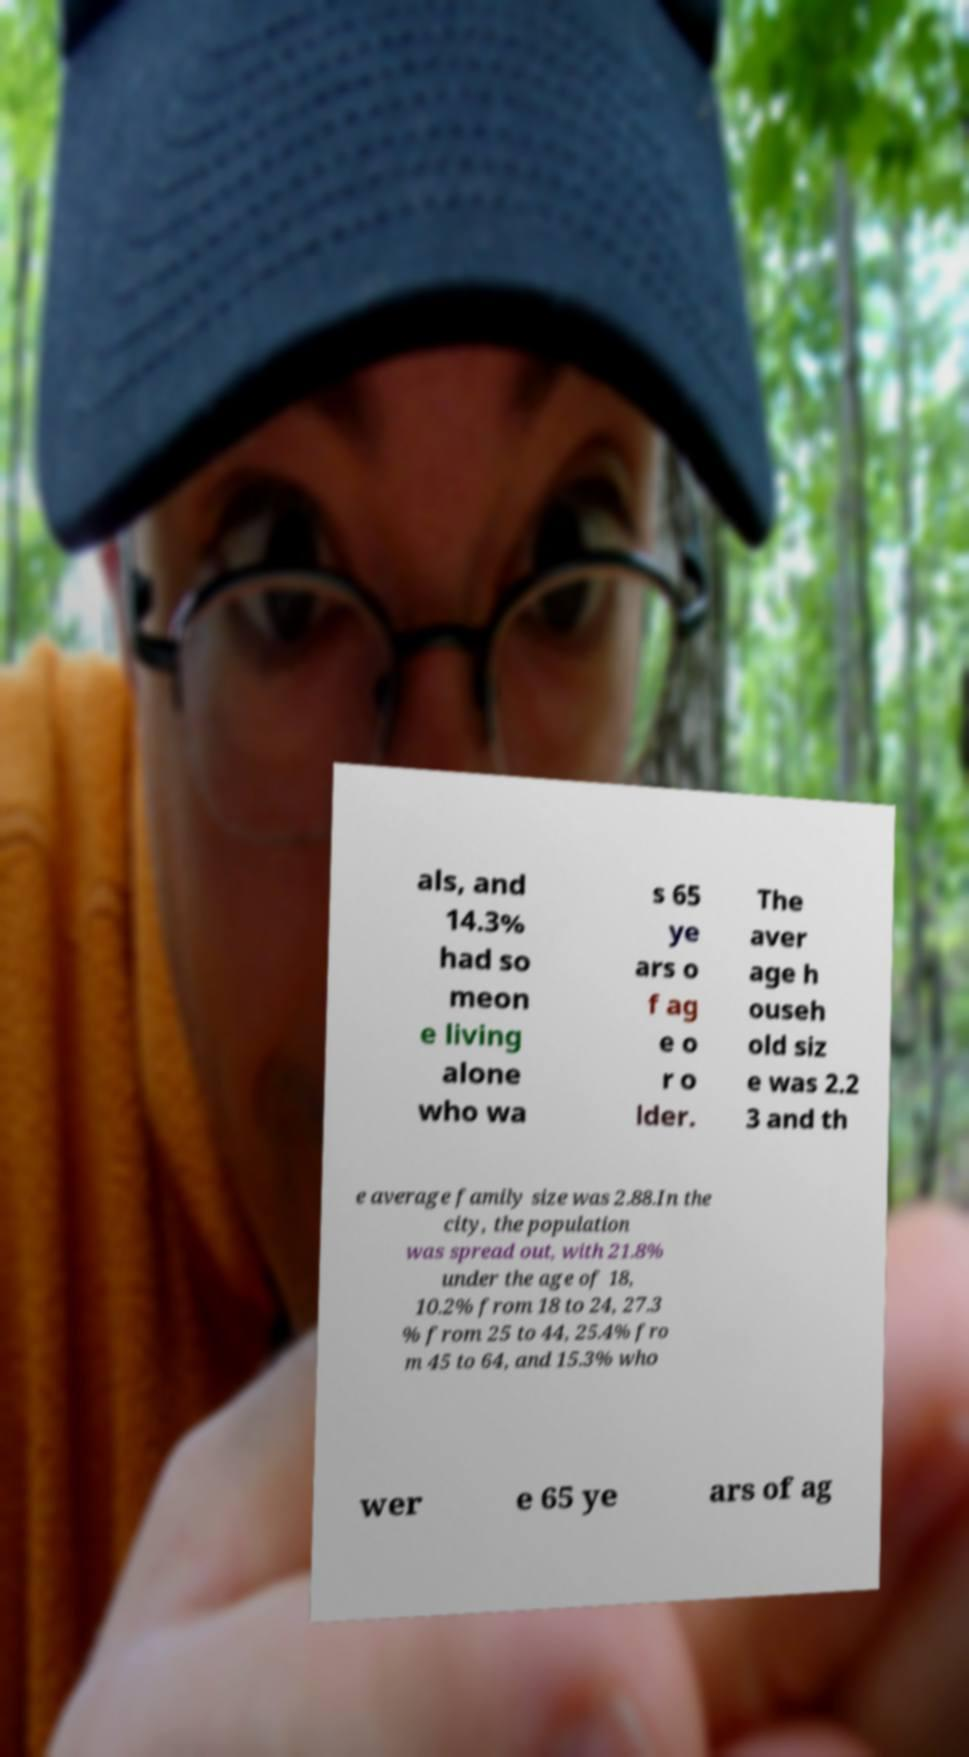I need the written content from this picture converted into text. Can you do that? als, and 14.3% had so meon e living alone who wa s 65 ye ars o f ag e o r o lder. The aver age h ouseh old siz e was 2.2 3 and th e average family size was 2.88.In the city, the population was spread out, with 21.8% under the age of 18, 10.2% from 18 to 24, 27.3 % from 25 to 44, 25.4% fro m 45 to 64, and 15.3% who wer e 65 ye ars of ag 